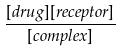Convert formula to latex. <formula><loc_0><loc_0><loc_500><loc_500>\frac { [ d r u g ] [ r e c e p t o r ] } { [ c o m p l e x ] }</formula> 